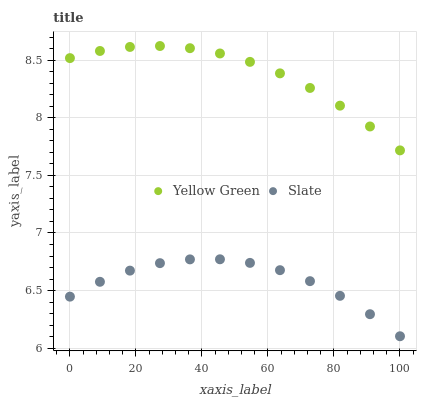Does Slate have the minimum area under the curve?
Answer yes or no. Yes. Does Yellow Green have the maximum area under the curve?
Answer yes or no. Yes. Does Yellow Green have the minimum area under the curve?
Answer yes or no. No. Is Yellow Green the smoothest?
Answer yes or no. Yes. Is Slate the roughest?
Answer yes or no. Yes. Is Yellow Green the roughest?
Answer yes or no. No. Does Slate have the lowest value?
Answer yes or no. Yes. Does Yellow Green have the lowest value?
Answer yes or no. No. Does Yellow Green have the highest value?
Answer yes or no. Yes. Is Slate less than Yellow Green?
Answer yes or no. Yes. Is Yellow Green greater than Slate?
Answer yes or no. Yes. Does Slate intersect Yellow Green?
Answer yes or no. No. 